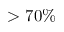<formula> <loc_0><loc_0><loc_500><loc_500>> 7 0 \%</formula> 